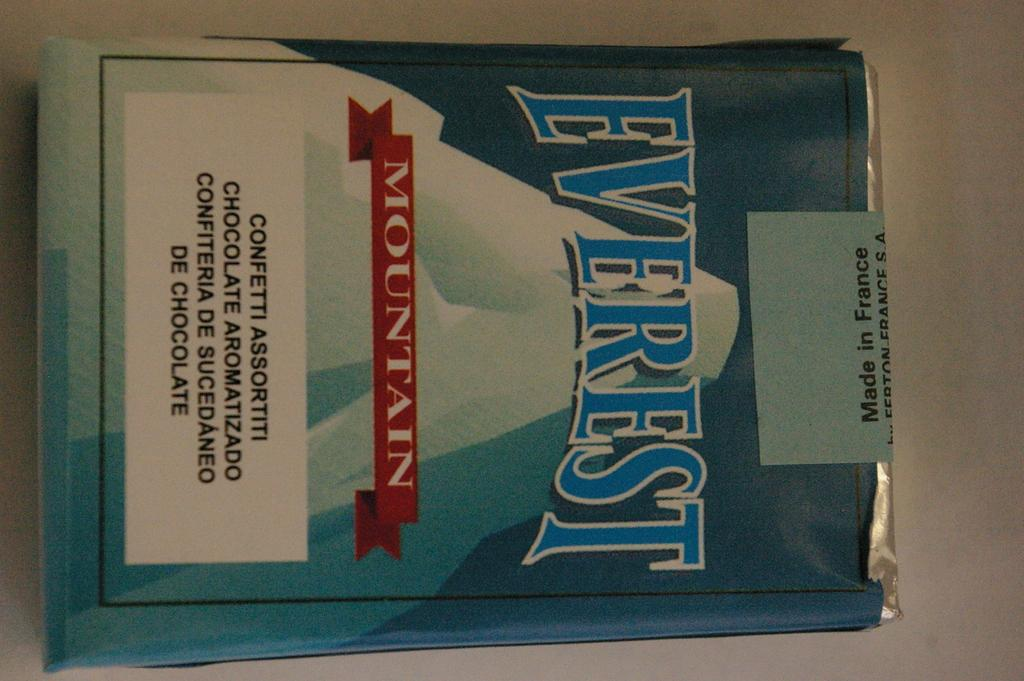Provide a one-sentence caption for the provided image. a new unopened pack of everest mountain branded cigarettes. 